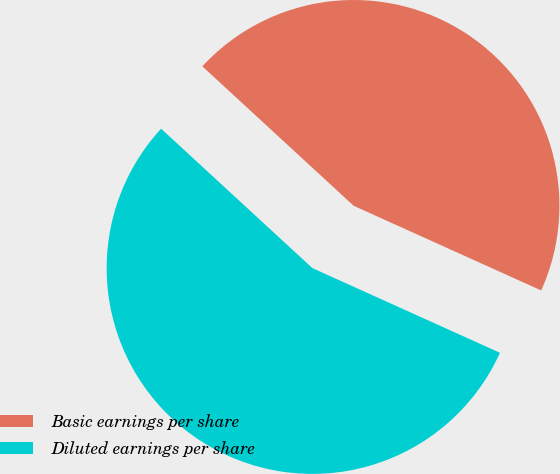Convert chart to OTSL. <chart><loc_0><loc_0><loc_500><loc_500><pie_chart><fcel>Basic earnings per share<fcel>Diluted earnings per share<nl><fcel>44.9%<fcel>55.1%<nl></chart> 